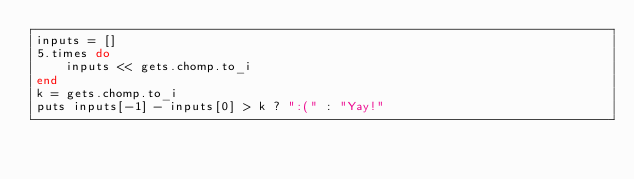Convert code to text. <code><loc_0><loc_0><loc_500><loc_500><_Ruby_>inputs = []
5.times do
    inputs << gets.chomp.to_i
end
k = gets.chomp.to_i
puts inputs[-1] - inputs[0] > k ? ":(" : "Yay!"</code> 